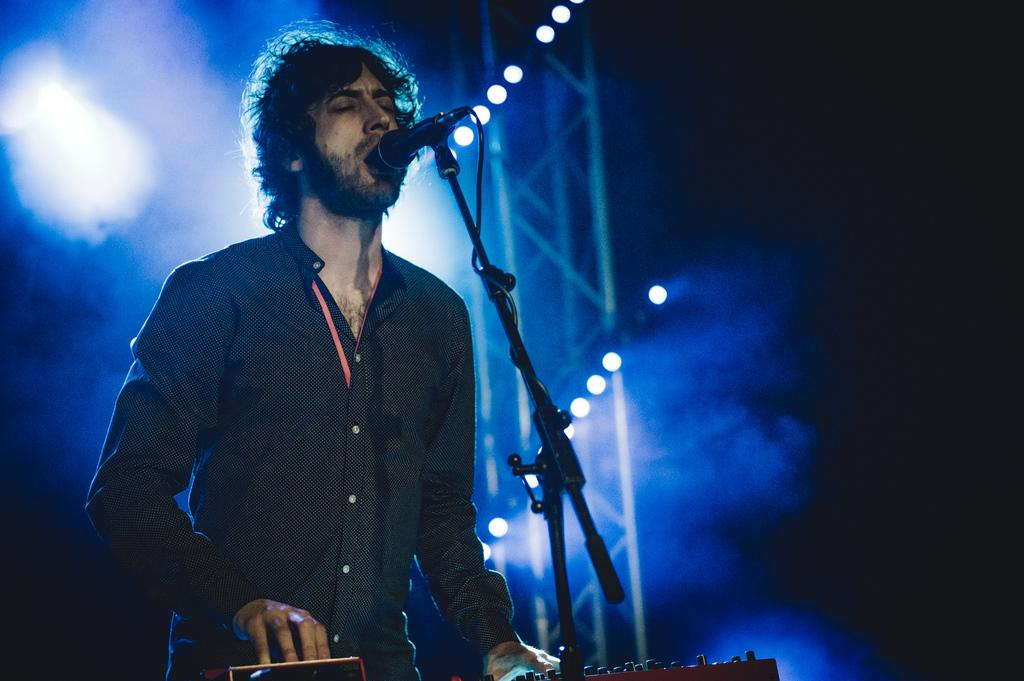What is the person in the image doing? The person in the image is singing. What object is in front of the person? There is a microphone in front of the person. What can be seen in the background of the image? There are lights visible in the background of the image. Can you see a straw in the person's hand in the image? There is no straw visible in the person's hand in the image. Is the person singing in a park in the image? The image does not provide information about the location of the person singing, so it cannot be determined if they are in a park. Is there an umbrella present in the image? There is no mention of an umbrella in the provided facts, and therefore it cannot be determined if one is present in the image. 